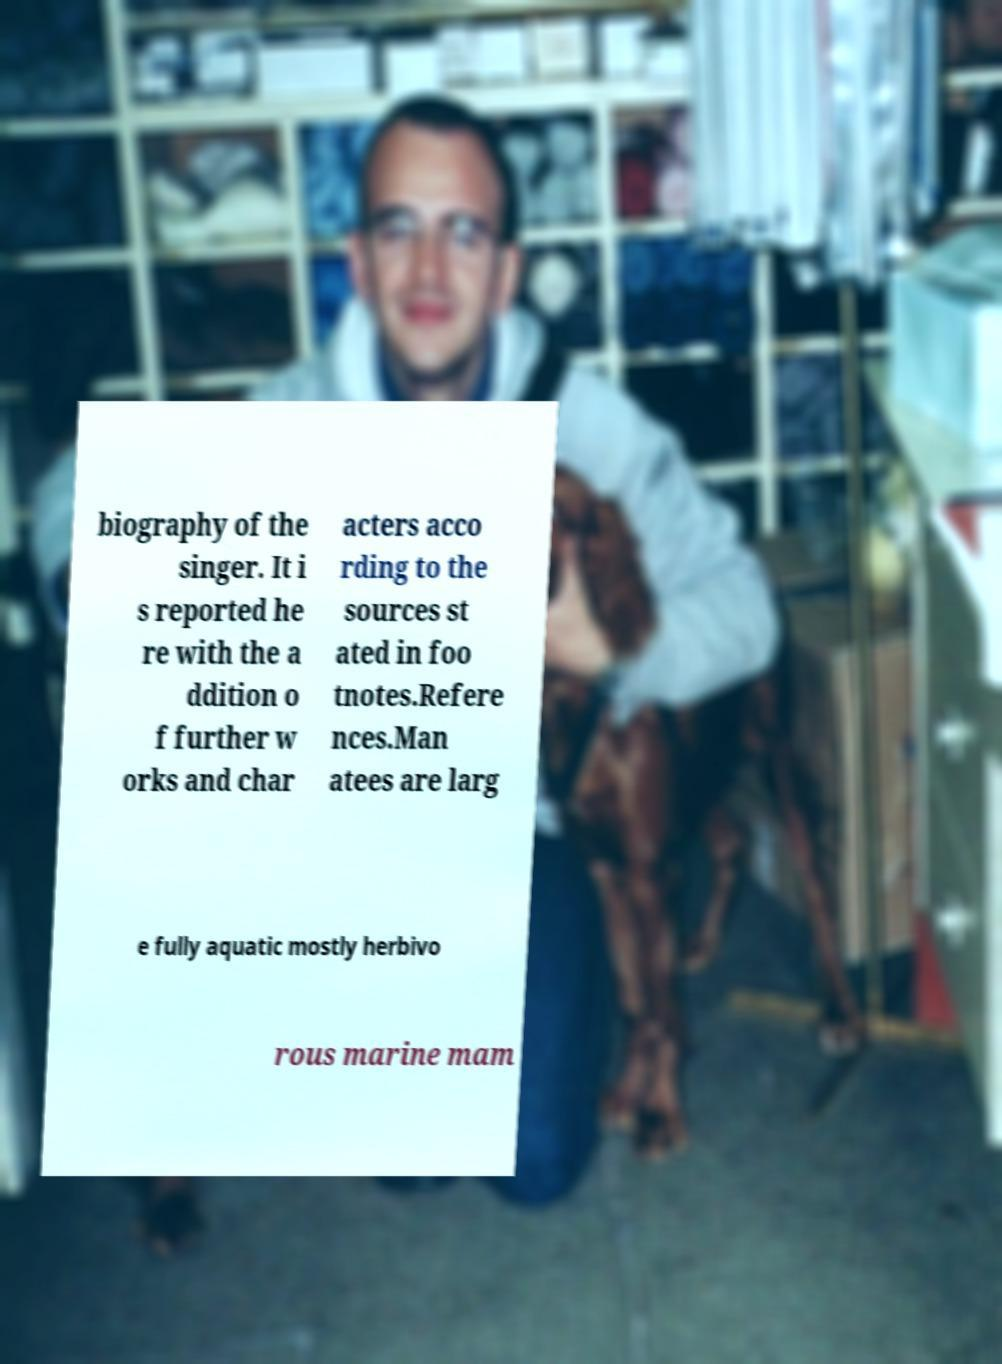I need the written content from this picture converted into text. Can you do that? biography of the singer. It i s reported he re with the a ddition o f further w orks and char acters acco rding to the sources st ated in foo tnotes.Refere nces.Man atees are larg e fully aquatic mostly herbivo rous marine mam 